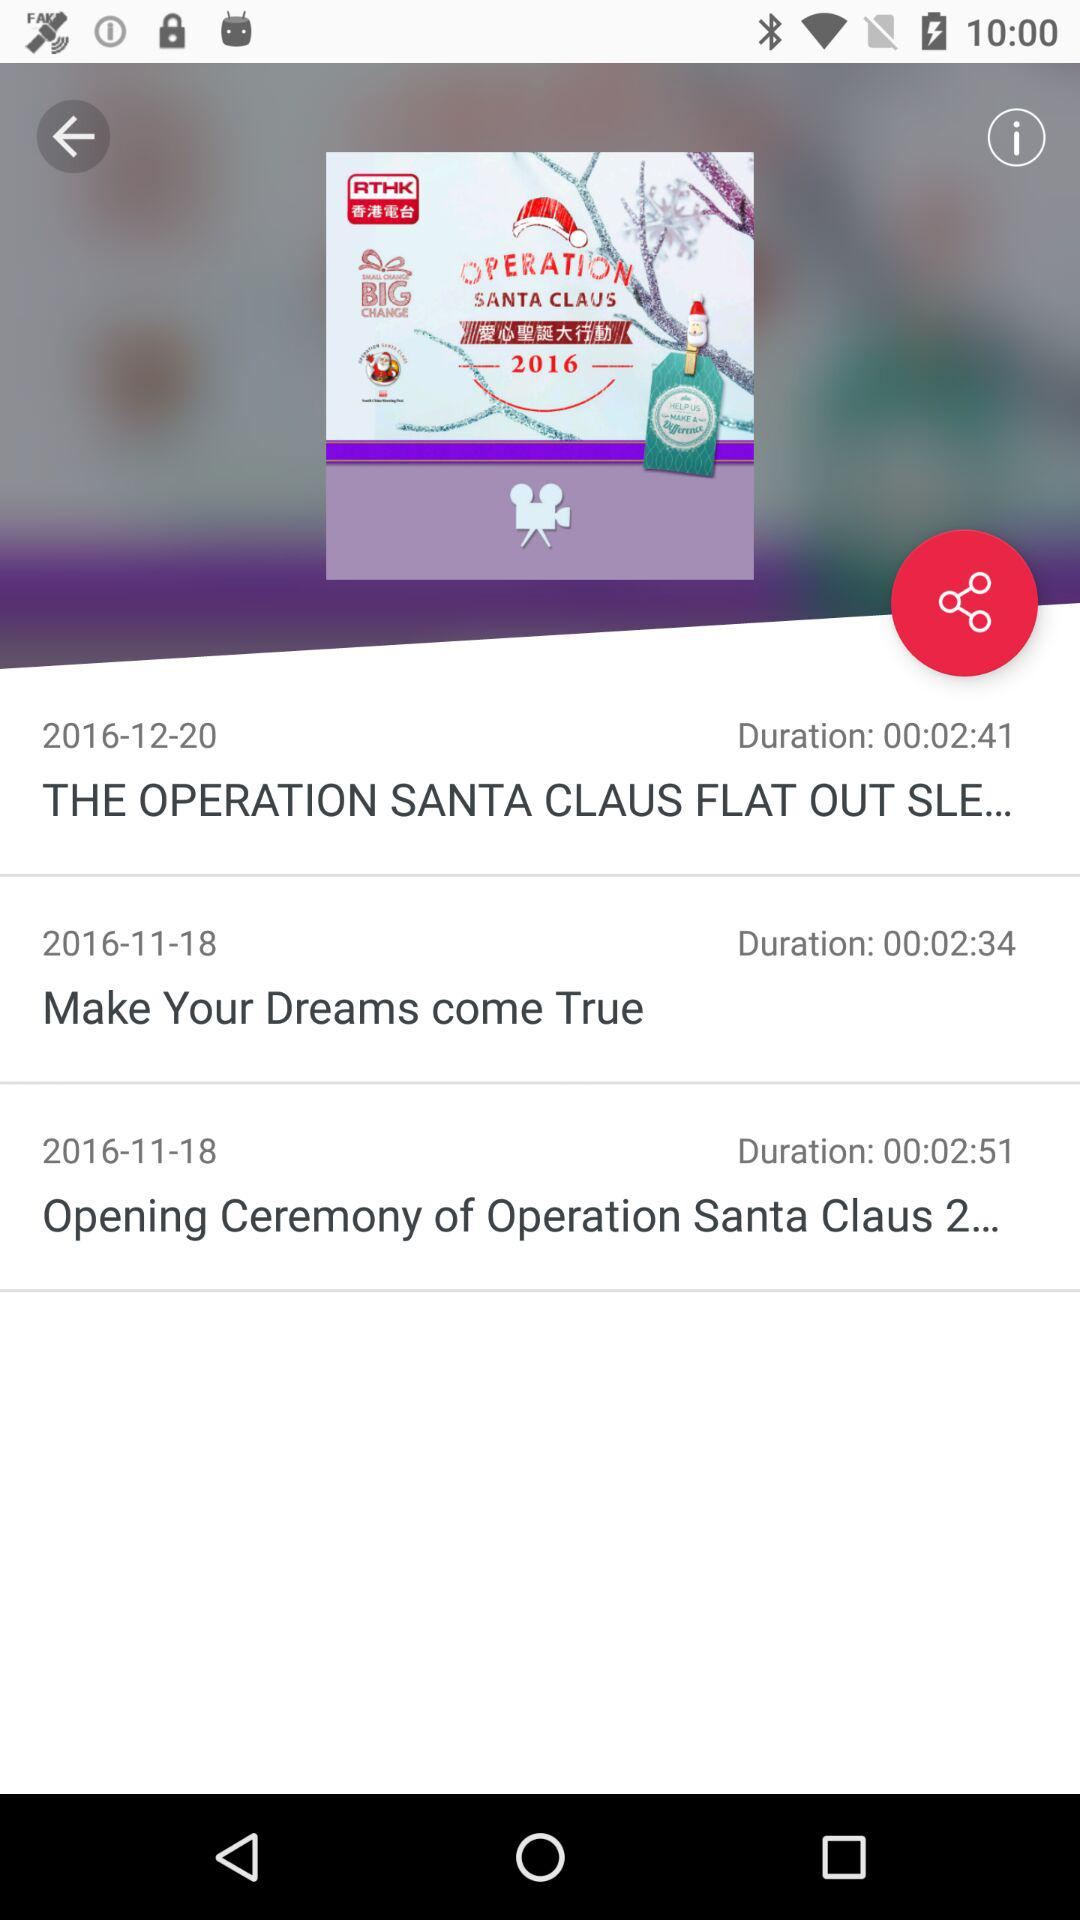What is the duration of the opening ceremony of operation Santa Claus 2? The duration is 00:02:51. 